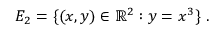<formula> <loc_0><loc_0><loc_500><loc_500>E _ { 2 } = \{ ( x , y ) \in \mathbb { R } ^ { 2 } \colon y = x ^ { 3 } \} \ .</formula> 